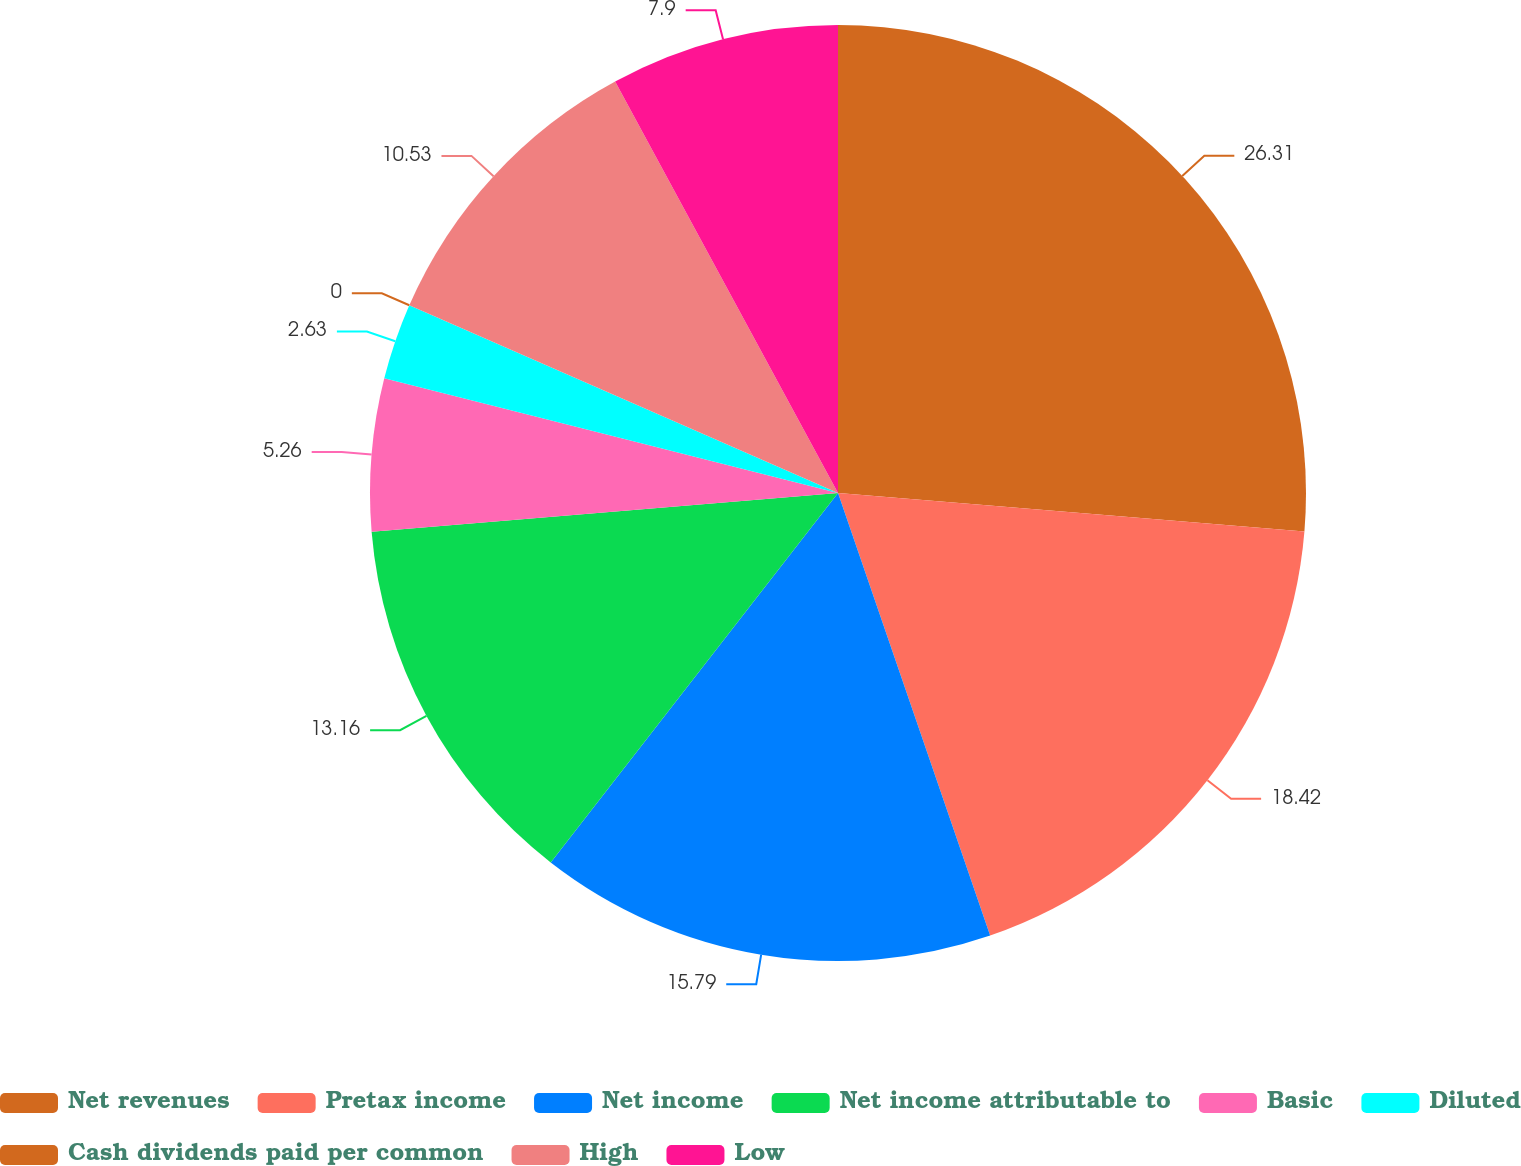Convert chart to OTSL. <chart><loc_0><loc_0><loc_500><loc_500><pie_chart><fcel>Net revenues<fcel>Pretax income<fcel>Net income<fcel>Net income attributable to<fcel>Basic<fcel>Diluted<fcel>Cash dividends paid per common<fcel>High<fcel>Low<nl><fcel>26.31%<fcel>18.42%<fcel>15.79%<fcel>13.16%<fcel>5.26%<fcel>2.63%<fcel>0.0%<fcel>10.53%<fcel>7.9%<nl></chart> 